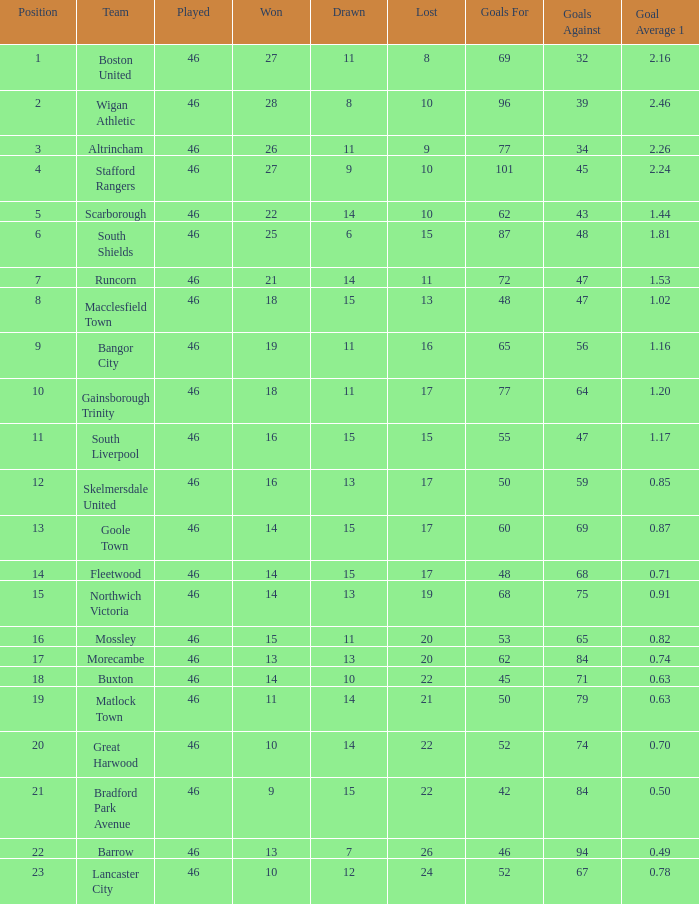Could you parse the entire table as a dict? {'header': ['Position', 'Team', 'Played', 'Won', 'Drawn', 'Lost', 'Goals For', 'Goals Against', 'Goal Average 1'], 'rows': [['1', 'Boston United', '46', '27', '11', '8', '69', '32', '2.16'], ['2', 'Wigan Athletic', '46', '28', '8', '10', '96', '39', '2.46'], ['3', 'Altrincham', '46', '26', '11', '9', '77', '34', '2.26'], ['4', 'Stafford Rangers', '46', '27', '9', '10', '101', '45', '2.24'], ['5', 'Scarborough', '46', '22', '14', '10', '62', '43', '1.44'], ['6', 'South Shields', '46', '25', '6', '15', '87', '48', '1.81'], ['7', 'Runcorn', '46', '21', '14', '11', '72', '47', '1.53'], ['8', 'Macclesfield Town', '46', '18', '15', '13', '48', '47', '1.02'], ['9', 'Bangor City', '46', '19', '11', '16', '65', '56', '1.16'], ['10', 'Gainsborough Trinity', '46', '18', '11', '17', '77', '64', '1.20'], ['11', 'South Liverpool', '46', '16', '15', '15', '55', '47', '1.17'], ['12', 'Skelmersdale United', '46', '16', '13', '17', '50', '59', '0.85'], ['13', 'Goole Town', '46', '14', '15', '17', '60', '69', '0.87'], ['14', 'Fleetwood', '46', '14', '15', '17', '48', '68', '0.71'], ['15', 'Northwich Victoria', '46', '14', '13', '19', '68', '75', '0.91'], ['16', 'Mossley', '46', '15', '11', '20', '53', '65', '0.82'], ['17', 'Morecambe', '46', '13', '13', '20', '62', '84', '0.74'], ['18', 'Buxton', '46', '14', '10', '22', '45', '71', '0.63'], ['19', 'Matlock Town', '46', '11', '14', '21', '50', '79', '0.63'], ['20', 'Great Harwood', '46', '10', '14', '22', '52', '74', '0.70'], ['21', 'Bradford Park Avenue', '46', '9', '15', '22', '42', '84', '0.50'], ['22', 'Barrow', '46', '13', '7', '26', '46', '94', '0.49'], ['23', 'Lancaster City', '46', '10', '12', '24', '52', '67', '0.78']]} How many points did Goole Town accumulate? 1.0. 